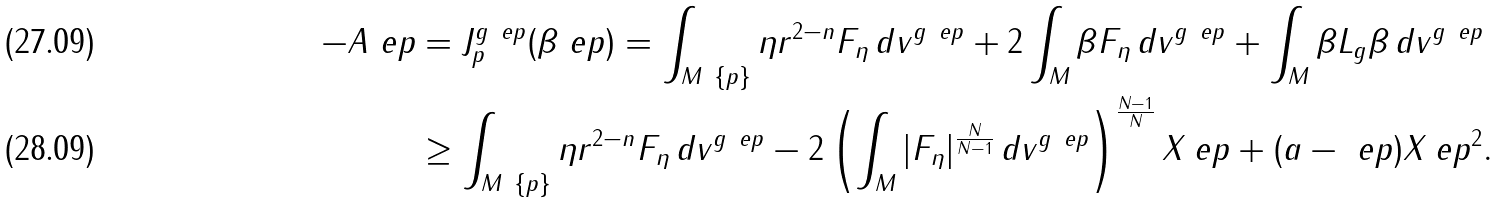<formula> <loc_0><loc_0><loc_500><loc_500>- A _ { \ } e p & = J ^ { g _ { \ } e p } _ { p } ( \beta _ { \ } e p ) = \int _ { M \ \{ p \} } \eta r ^ { 2 - n } F _ { \eta } \, d v ^ { g _ { \ } e p } + 2 \int _ { M } \beta F _ { \eta } \, d v ^ { g _ { \ } e p } + \int _ { M } \beta L _ { g } \beta \, d v ^ { g _ { \ } e p } \\ & \geq \int _ { M \ \{ p \} } \eta r ^ { 2 - n } F _ { \eta } \, d v ^ { g _ { \ } e p } - 2 \left ( \int _ { M } | F _ { \eta } | ^ { \frac { N } { N - 1 } } \, d v ^ { g _ { \ } e p } \right ) ^ { \frac { N - 1 } { N } } X _ { \ } e p + ( a - \ e p ) X _ { \ } e p ^ { 2 } .</formula> 